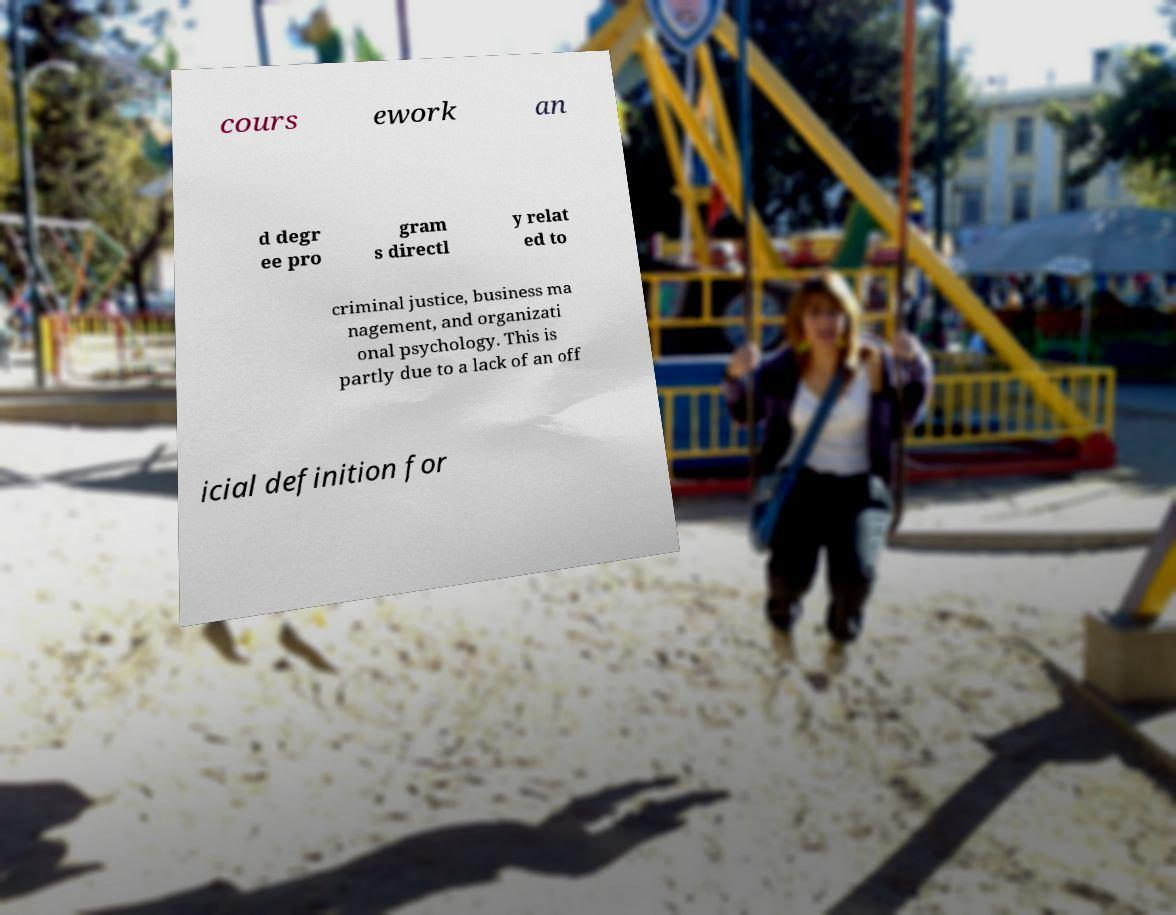Please read and relay the text visible in this image. What does it say? cours ework an d degr ee pro gram s directl y relat ed to criminal justice, business ma nagement, and organizati onal psychology. This is partly due to a lack of an off icial definition for 